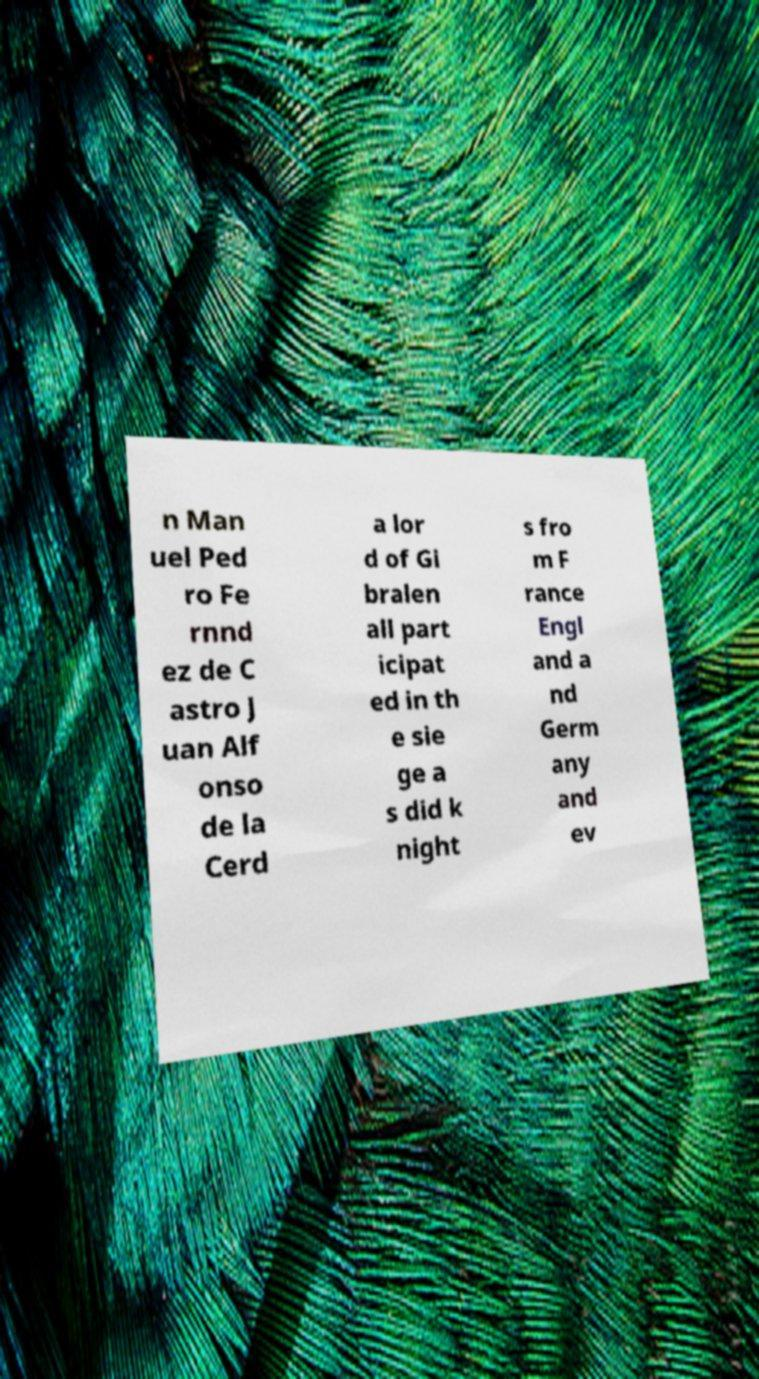Could you extract and type out the text from this image? n Man uel Ped ro Fe rnnd ez de C astro J uan Alf onso de la Cerd a lor d of Gi bralen all part icipat ed in th e sie ge a s did k night s fro m F rance Engl and a nd Germ any and ev 